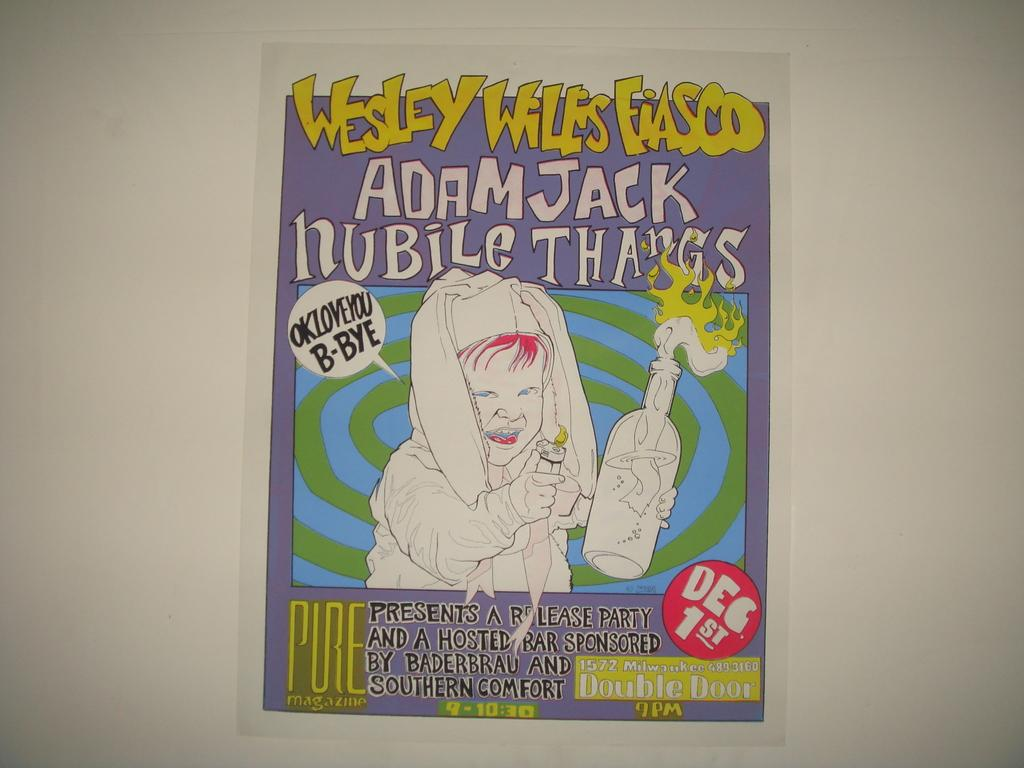<image>
Render a clear and concise summary of the photo. Information about a release party for Wesley Wiles Fianco. 